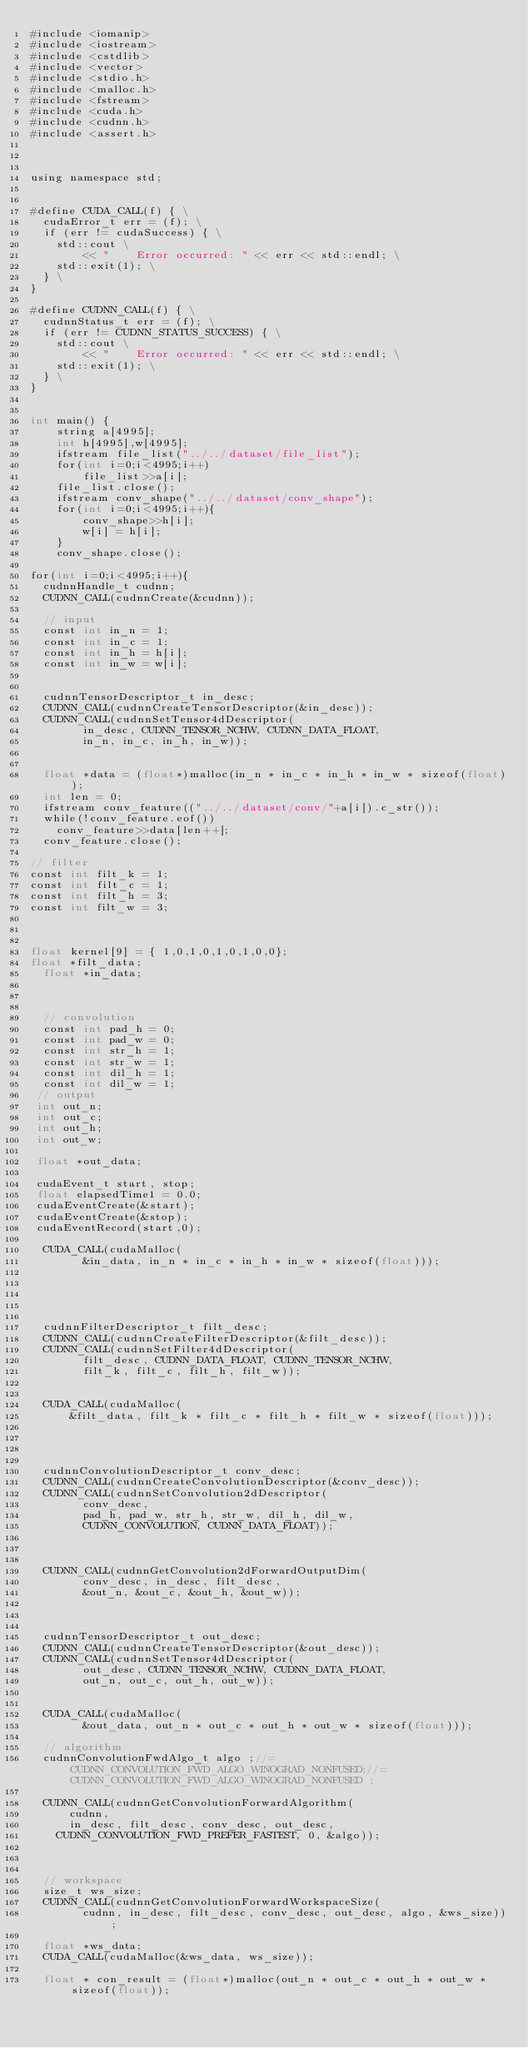Convert code to text. <code><loc_0><loc_0><loc_500><loc_500><_Cuda_>#include <iomanip>
#include <iostream>
#include <cstdlib>
#include <vector>
#include <stdio.h>
#include <malloc.h>
#include <fstream>
#include <cuda.h>
#include <cudnn.h>
#include <assert.h>



using namespace std;


#define CUDA_CALL(f) { \
  cudaError_t err = (f); \
  if (err != cudaSuccess) { \
    std::cout \
        << "    Error occurred: " << err << std::endl; \
    std::exit(1); \
  } \
}

#define CUDNN_CALL(f) { \
  cudnnStatus_t err = (f); \
  if (err != CUDNN_STATUS_SUCCESS) { \
    std::cout \
        << "    Error occurred: " << err << std::endl; \
    std::exit(1); \
  } \
}


int main() {
    string a[4995];
	int h[4995],w[4995];
	ifstream file_list("../../dataset/file_list");
	for(int i=0;i<4995;i++)
		file_list>>a[i];
	file_list.close();
	ifstream conv_shape("../../dataset/conv_shape");
	for(int i=0;i<4995;i++){
		conv_shape>>h[i];
		w[i] = h[i];
	}
	conv_shape.close();

for(int i=0;i<4995;i++){
  cudnnHandle_t cudnn;
  CUDNN_CALL(cudnnCreate(&cudnn));

  // input
  const int in_n = 1;
  const int in_c = 1;
  const int in_h = h[i];
  const int in_w = w[i];


  cudnnTensorDescriptor_t in_desc;
  CUDNN_CALL(cudnnCreateTensorDescriptor(&in_desc));
  CUDNN_CALL(cudnnSetTensor4dDescriptor(
        in_desc, CUDNN_TENSOR_NCHW, CUDNN_DATA_FLOAT,
        in_n, in_c, in_h, in_w));


  float *data = (float*)malloc(in_n * in_c * in_h * in_w * sizeof(float));
  int len = 0;
  ifstream conv_feature(("../../dataset/conv/"+a[i]).c_str());
  while(!conv_feature.eof())
    conv_feature>>data[len++];
  conv_feature.close();

// filter
const int filt_k = 1;
const int filt_c = 1;
const int filt_h = 3;
const int filt_w = 3;



float kernel[9] = { 1,0,1,0,1,0,1,0,0};
float *filt_data;
  float *in_data;



  // convolution
  const int pad_h = 0;
  const int pad_w = 0;
  const int str_h = 1;
  const int str_w = 1;
  const int dil_h = 1;
  const int dil_w = 1;
 // output
 int out_n;
 int out_c;
 int out_h;
 int out_w;

 float *out_data;

 cudaEvent_t start, stop;
 float elapsedTime1 = 0.0;
 cudaEventCreate(&start);
 cudaEventCreate(&stop);
 cudaEventRecord(start,0);

  CUDA_CALL(cudaMalloc(
        &in_data, in_n * in_c * in_h * in_w * sizeof(float)));


  


  cudnnFilterDescriptor_t filt_desc;
  CUDNN_CALL(cudnnCreateFilterDescriptor(&filt_desc));
  CUDNN_CALL(cudnnSetFilter4dDescriptor(
        filt_desc, CUDNN_DATA_FLOAT, CUDNN_TENSOR_NCHW,
        filt_k, filt_c, filt_h, filt_w));


  CUDA_CALL(cudaMalloc(
      &filt_data, filt_k * filt_c * filt_h * filt_w * sizeof(float)));




  cudnnConvolutionDescriptor_t conv_desc;
  CUDNN_CALL(cudnnCreateConvolutionDescriptor(&conv_desc));
  CUDNN_CALL(cudnnSetConvolution2dDescriptor(
        conv_desc,
        pad_h, pad_w, str_h, str_w, dil_h, dil_w,
        CUDNN_CONVOLUTION, CUDNN_DATA_FLOAT));

 

  CUDNN_CALL(cudnnGetConvolution2dForwardOutputDim(
        conv_desc, in_desc, filt_desc,
        &out_n, &out_c, &out_h, &out_w));



  cudnnTensorDescriptor_t out_desc;
  CUDNN_CALL(cudnnCreateTensorDescriptor(&out_desc));
  CUDNN_CALL(cudnnSetTensor4dDescriptor(
        out_desc, CUDNN_TENSOR_NCHW, CUDNN_DATA_FLOAT,
        out_n, out_c, out_h, out_w));

 
  CUDA_CALL(cudaMalloc(
        &out_data, out_n * out_c * out_h * out_w * sizeof(float)));

  // algorithm
  cudnnConvolutionFwdAlgo_t algo ;//=CUDNN_CONVOLUTION_FWD_ALGO_WINOGRAD_NONFUSED;//= CUDNN_CONVOLUTION_FWD_ALGO_WINOGRAD_NONFUSED ;

  CUDNN_CALL(cudnnGetConvolutionForwardAlgorithm(
      cudnn,
      in_desc, filt_desc, conv_desc, out_desc,
    CUDNN_CONVOLUTION_FWD_PREFER_FASTEST, 0, &algo));



  // workspace
  size_t ws_size;
  CUDNN_CALL(cudnnGetConvolutionForwardWorkspaceSize(
        cudnn, in_desc, filt_desc, conv_desc, out_desc, algo, &ws_size));

  float *ws_data;
  CUDA_CALL(cudaMalloc(&ws_data, ws_size));

  float * con_result = (float*)malloc(out_n * out_c * out_h * out_w *sizeof(float));</code> 